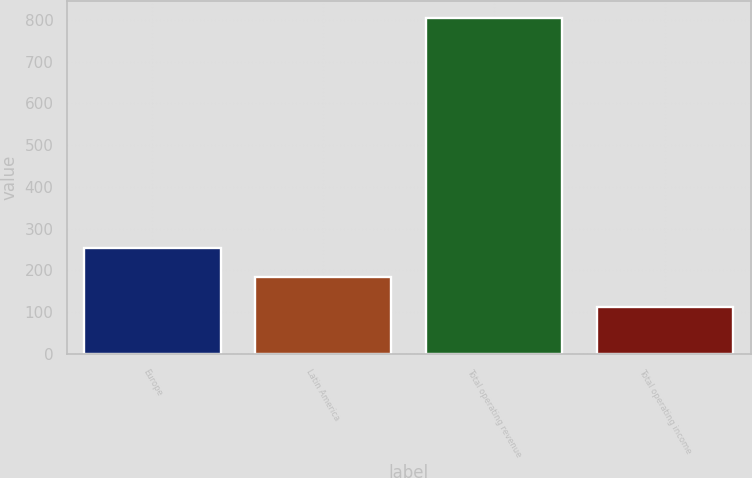Convert chart to OTSL. <chart><loc_0><loc_0><loc_500><loc_500><bar_chart><fcel>Europe<fcel>Latin America<fcel>Total operating revenue<fcel>Total operating income<nl><fcel>253.6<fcel>183.9<fcel>803.6<fcel>111.4<nl></chart> 